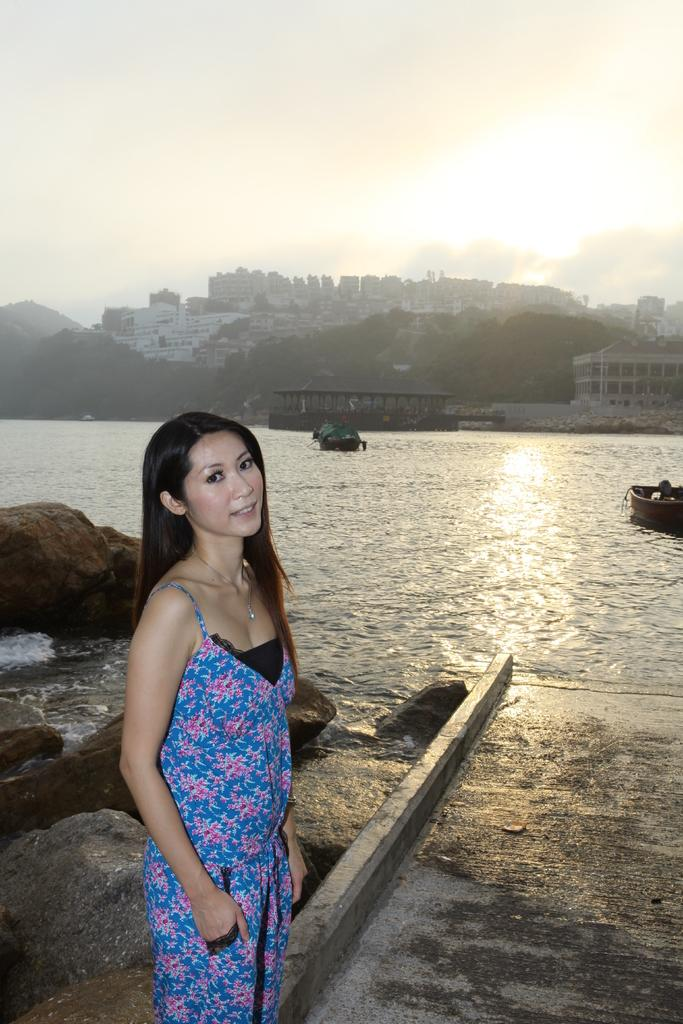Who is the main subject in the image? There is a woman standing in the center of the image. What is the woman standing on? The woman is standing on the ground. What can be seen in the background of the image? There are rocks, boats, hills, buildings, water, and the sky visible in the background of the image. What is the condition of the sky in the image? The sky is visible in the background of the image, and there are clouds present. Where is the garden located in the image? There is no garden present in the image. What type of carriage can be seen in the image? There is no carriage present in the image. 